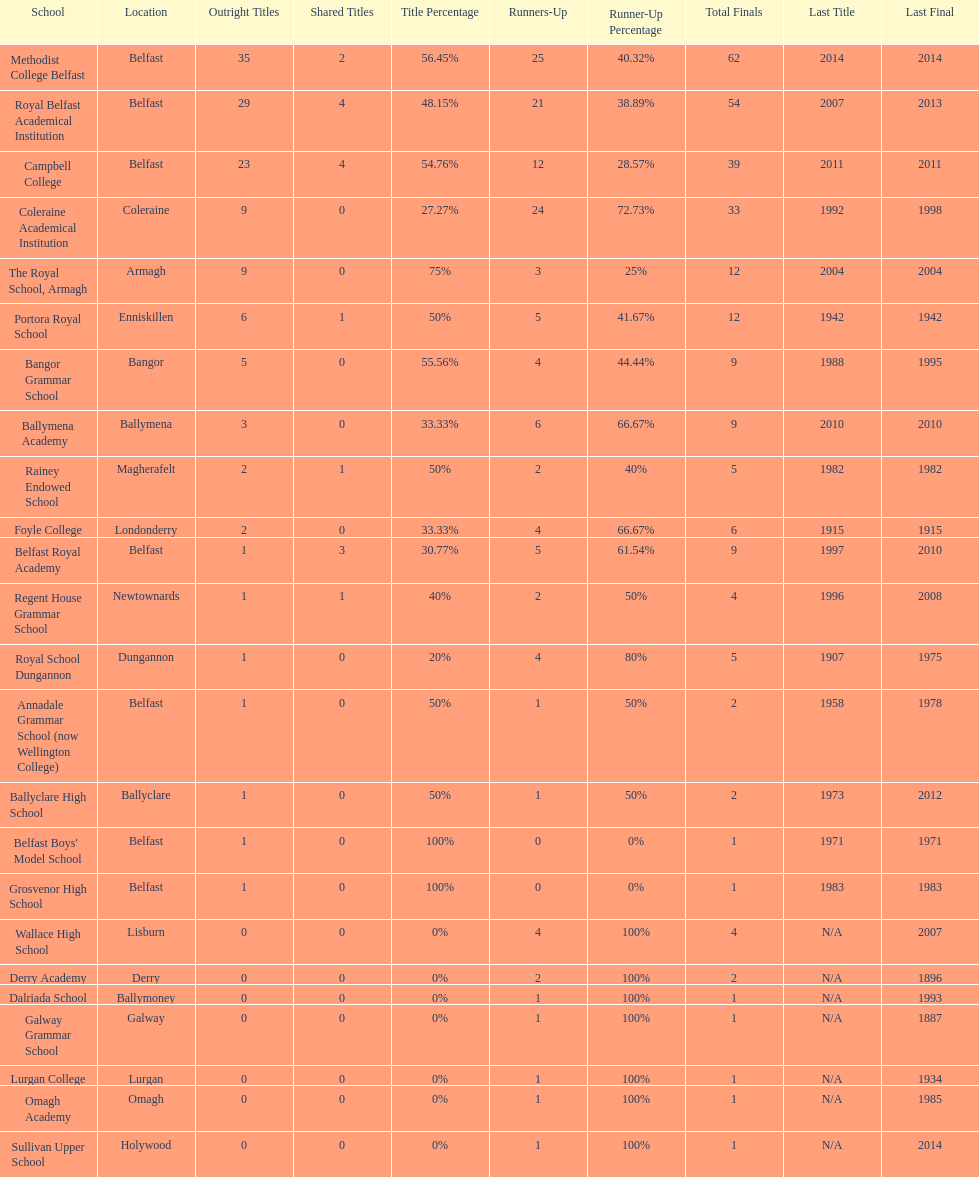Which schools have the largest number of shared titles? Royal Belfast Academical Institution, Campbell College. 